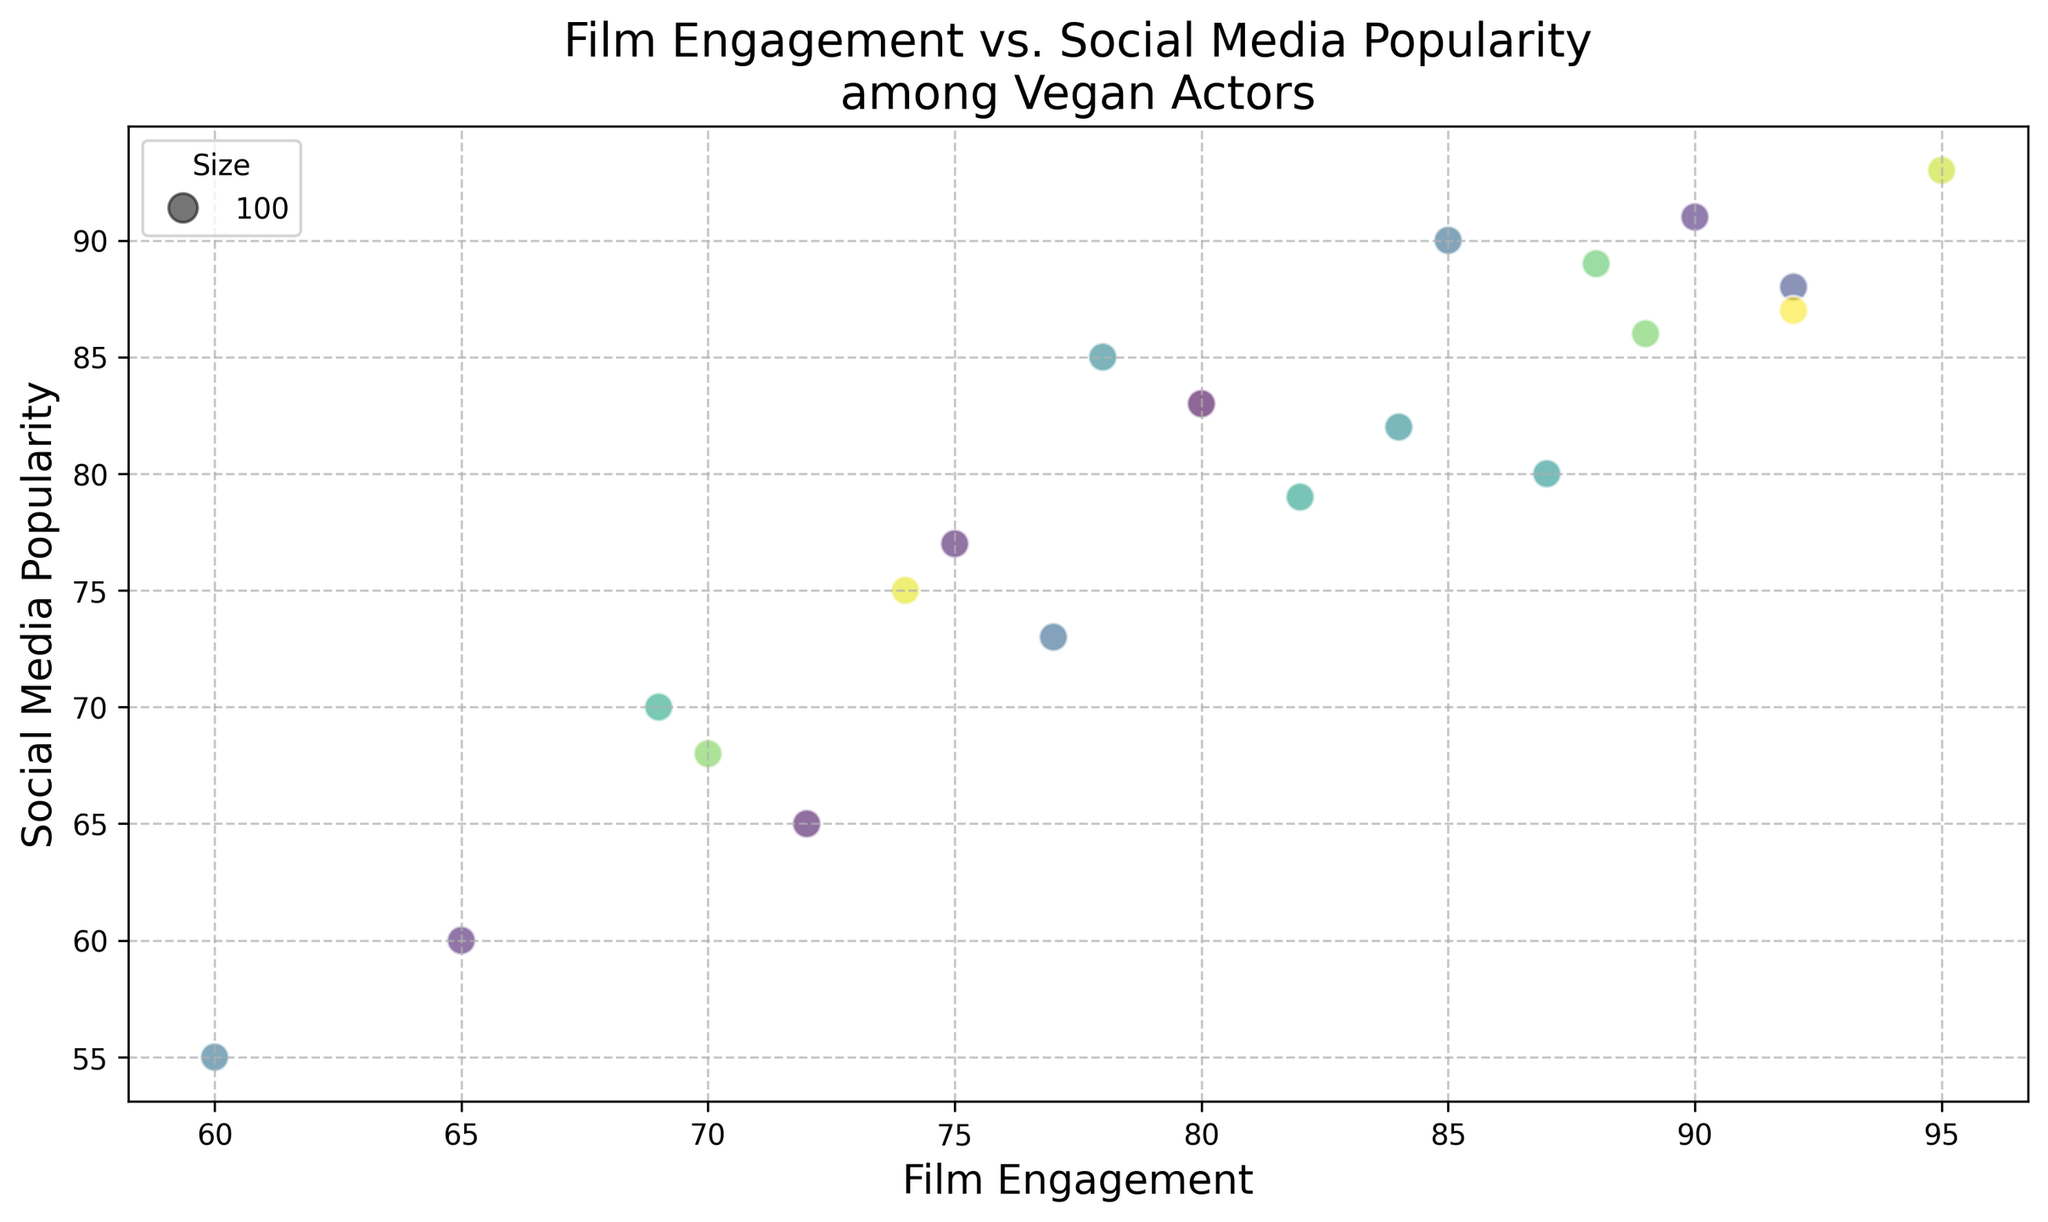What's the highest value of Film Engagement and which actor has it? To find the highest value of Film Engagement, scan the scatter plot for the point positioned farthest along the x-axis. Identify the actor associated with this position from the provided data. Actor E has a Film Engagement of 95, the highest value on the plot.
Answer: Actor E Which actor has the lowest Social Media Popularity? Look for the data point closest to the origin along the y-axis. This point will have the smallest Social Media Popularity value. Actor J's point is the lowest on the y-axis with a Social Media Popularity of 55.
Answer: Actor J Who has higher Film Engagement, Actor D or Actor T? Identify the positions of Actor D and Actor T on the x-axis. Actor D is at 69, while Actor T is at 80. Since 80 is greater than 69, Actor T has a higher Film Engagement.
Answer: Actor T What's the average Film Engagement among actors with a Social Media Popularity greater than 80? Determine which actors have Social Media Popularity above 80: Actors A, B, C, E, I, L, P, R, and T. Sum their Film Engagement values (85 + 78 + 92 + 95 + 88 + 90 + 92 + 89 + 80 = 789) and divide by the number of these actors (9). 789 / 9 equals approximately 87.67.
Answer: 87.67 Which actor has the closest combination of Film Engagement and Social Media Popularity values? Identify the point where the x and y values are the most closely matched. Actor L, with Film Engagement of 90 and Social Media Popularity of 91, has the values most nearly equal to each other.
Answer: Actor L Who is more popular on social media, Actor G or Actor K? Locate Actors G and K on the y-axis. Actor G has a Social Media Popularity of 80, while Actor K has 79. Since 80 is greater than 79, Actor G is more popular on social media.
Answer: Actor G What's the difference in Social Media Popularity between the actor with the highest Film Engagement and the actor with the lowest Film Engagement? Identify the actors with the highest (Actor E with 95) and lowest (Actor J with 60) Film Engagement. Their Social Media Popularities are 93 and 55 respectively. The difference is 93 - 55 = 38.
Answer: 38 Is there a trend that suggests higher Film Engagement leads to higher Social Media Popularity? Observing the overall distribution of the points on the scatter plot, notice whether points are slanting upwards from left to right. There is a visible increasing pattern indicating that higher Film Engagement generally correlates with higher Social Media Popularity.
Answer: Yes What's the median value of Social Media Popularity? Order the Social Media Popularity values: 55, 60, 65, 68, 70, 73, 75, 77, 80, 82, 83, 85, 86, 87, 88, 89, 90, 91, 93. The median value (middle point in the ordered list) is 82.
Answer: 82 